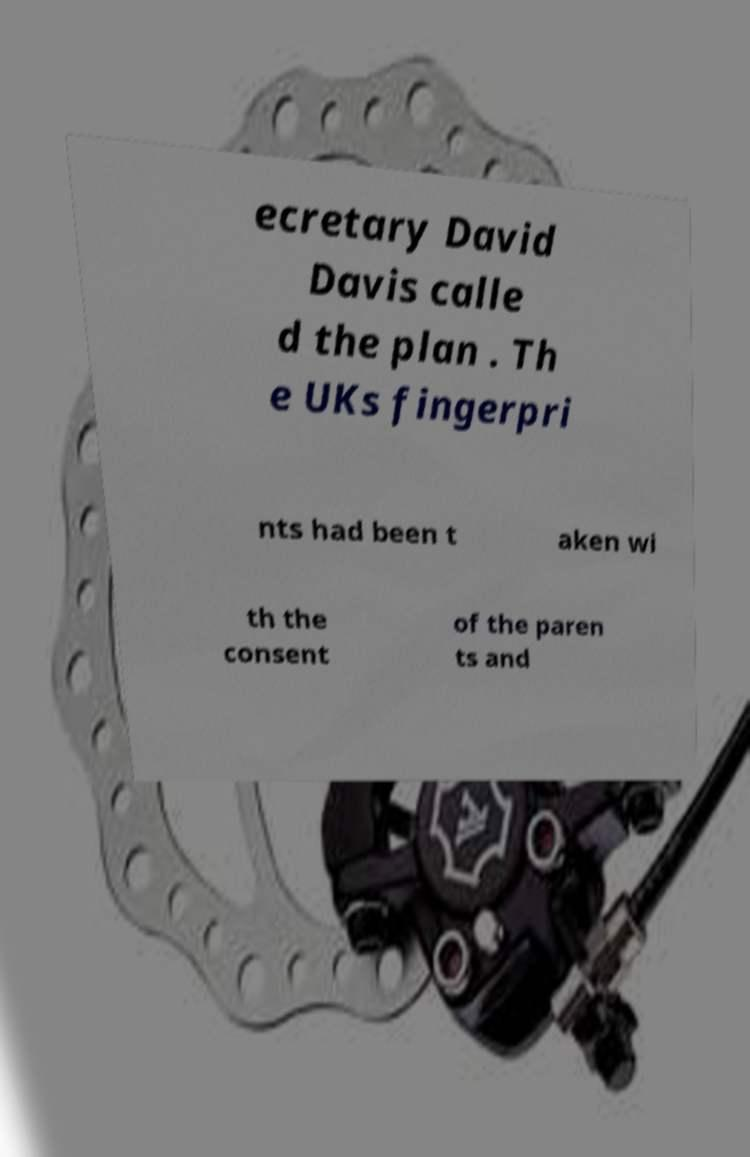There's text embedded in this image that I need extracted. Can you transcribe it verbatim? ecretary David Davis calle d the plan . Th e UKs fingerpri nts had been t aken wi th the consent of the paren ts and 